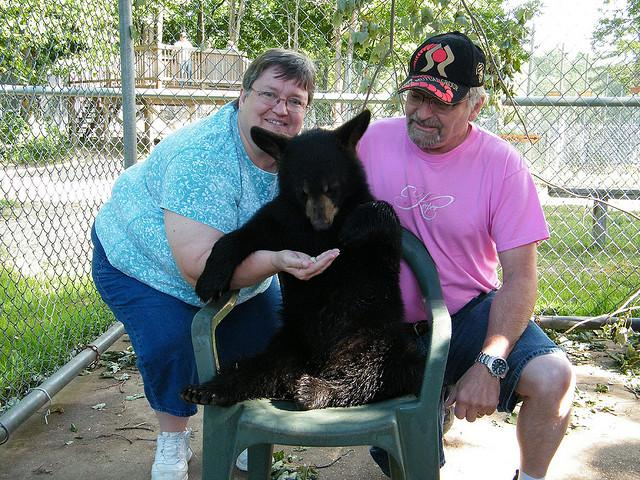What is the woman doing with the bear? Please explain your reasoning. feeding it. She has food in her hand and is holding it close to his mouth. 